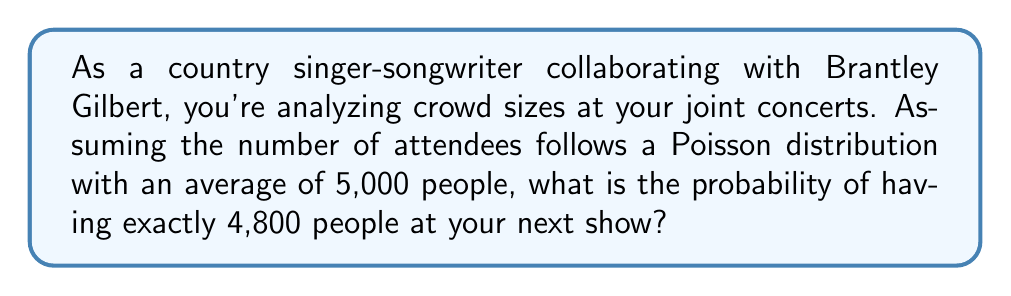Teach me how to tackle this problem. To solve this problem, we'll use the Poisson distribution formula:

$$P(X = k) = \frac{e^{-\lambda} \lambda^k}{k!}$$

Where:
$\lambda$ = average number of events (average crowd size) = 5,000
$k$ = specific number of events (crowd size we're calculating for) = 4,800
$e$ = Euler's number ≈ 2.71828

Step 1: Substitute the values into the formula
$$P(X = 4800) = \frac{e^{-5000} 5000^{4800}}{4800!}$$

Step 2: Calculate using a scientific calculator or computer program due to the large numbers involved. The result is approximately:

$$P(X = 4800) \approx 0.005636$$

Step 3: Convert to percentage
0.005636 * 100 ≈ 0.5636%

This means there's about a 0.5636% chance of having exactly 4,800 people at your next concert, assuming the Poisson distribution model holds true for your concert attendance.
Answer: 0.5636% 